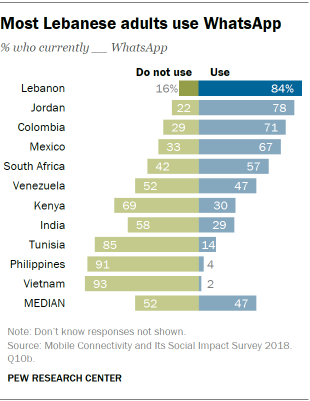Give some essential details in this illustration. A recent survey in Lebanon indicates that only 0.16% of adults do not use Whatsapp. In India, a smaller percentage of people do not use Whatsapp compared to the percentage of people who use Whatsapp in Mexico, according to recent data. 